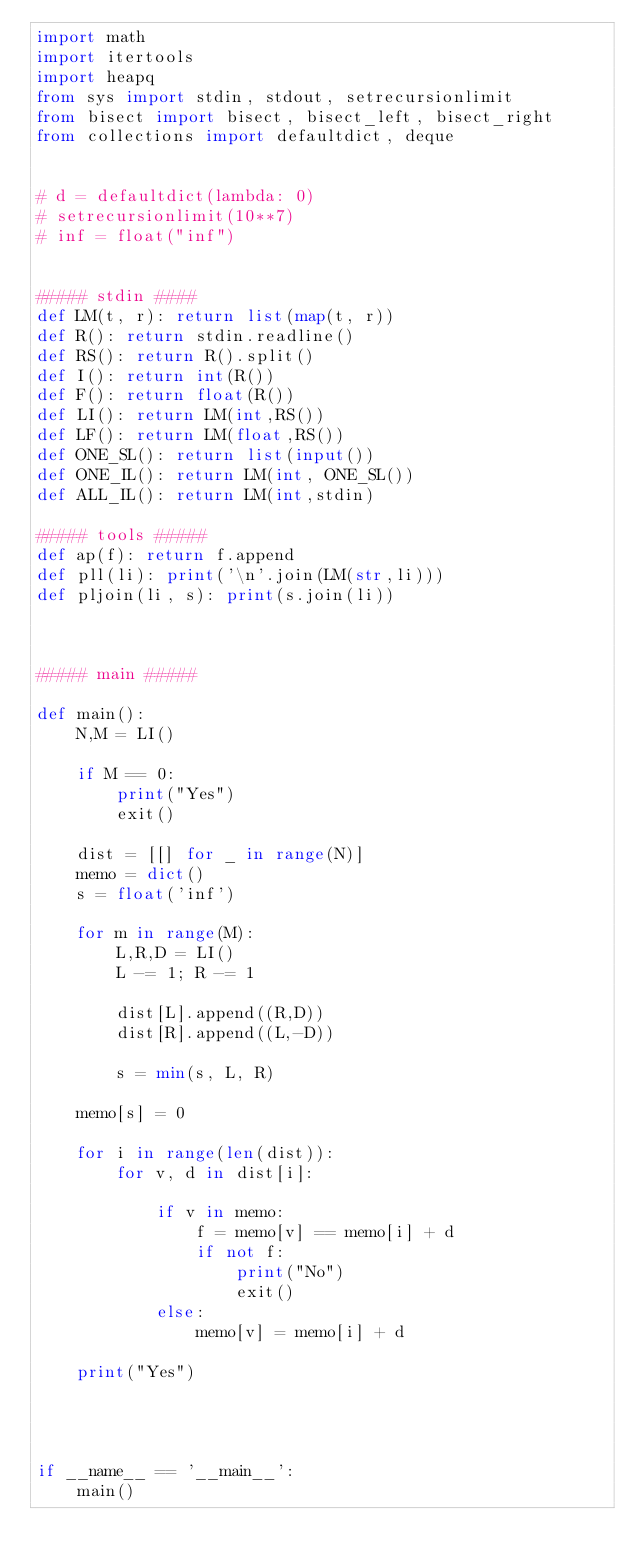<code> <loc_0><loc_0><loc_500><loc_500><_Python_>import math
import itertools
import heapq
from sys import stdin, stdout, setrecursionlimit
from bisect import bisect, bisect_left, bisect_right
from collections import defaultdict, deque


# d = defaultdict(lambda: 0)
# setrecursionlimit(10**7)
# inf = float("inf")


##### stdin ####
def LM(t, r): return list(map(t, r))
def R(): return stdin.readline()
def RS(): return R().split()
def I(): return int(R())
def F(): return float(R())
def LI(): return LM(int,RS())
def LF(): return LM(float,RS())
def ONE_SL(): return list(input())
def ONE_IL(): return LM(int, ONE_SL())
def ALL_IL(): return LM(int,stdin)

##### tools #####
def ap(f): return f.append
def pll(li): print('\n'.join(LM(str,li)))
def pljoin(li, s): print(s.join(li))



##### main #####

def main():
	N,M = LI()

	if M == 0:
		print("Yes")
		exit()

	dist = [[] for _ in range(N)]
	memo = dict()
	s = float('inf')

	for m in range(M):
		L,R,D = LI()
		L -= 1; R -= 1

		dist[L].append((R,D))
		dist[R].append((L,-D))

		s = min(s, L, R)

	memo[s] = 0

	for i in range(len(dist)):
		for v, d in dist[i]:

			if v in memo:
				f = memo[v] == memo[i] + d
				if not f:
					print("No")
					exit()
			else:
				memo[v] = memo[i] + d

	print("Yes")




if __name__ == '__main__':
	main()</code> 